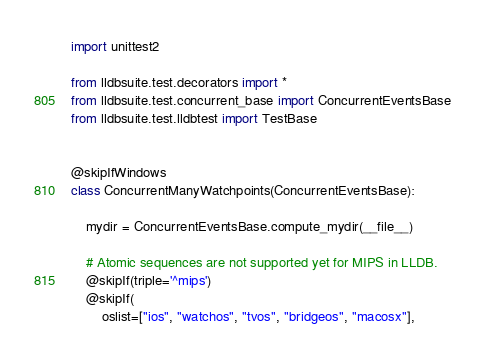<code> <loc_0><loc_0><loc_500><loc_500><_Python_>import unittest2

from lldbsuite.test.decorators import *
from lldbsuite.test.concurrent_base import ConcurrentEventsBase
from lldbsuite.test.lldbtest import TestBase


@skipIfWindows
class ConcurrentManyWatchpoints(ConcurrentEventsBase):

    mydir = ConcurrentEventsBase.compute_mydir(__file__)

    # Atomic sequences are not supported yet for MIPS in LLDB.
    @skipIf(triple='^mips')
    @skipIf(
        oslist=["ios", "watchos", "tvos", "bridgeos", "macosx"],</code> 